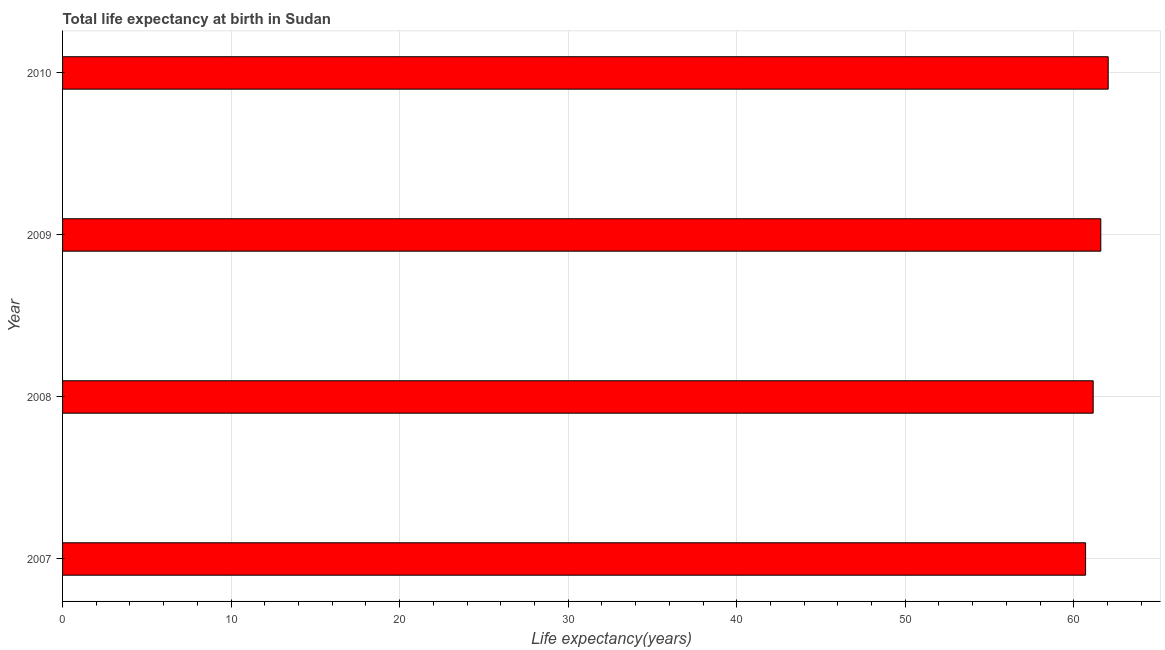Does the graph contain any zero values?
Provide a succinct answer. No. What is the title of the graph?
Your answer should be very brief. Total life expectancy at birth in Sudan. What is the label or title of the X-axis?
Offer a very short reply. Life expectancy(years). What is the label or title of the Y-axis?
Make the answer very short. Year. What is the life expectancy at birth in 2009?
Ensure brevity in your answer.  61.6. Across all years, what is the maximum life expectancy at birth?
Provide a short and direct response. 62.04. Across all years, what is the minimum life expectancy at birth?
Provide a short and direct response. 60.7. In which year was the life expectancy at birth maximum?
Your answer should be compact. 2010. In which year was the life expectancy at birth minimum?
Your answer should be compact. 2007. What is the sum of the life expectancy at birth?
Give a very brief answer. 245.5. What is the difference between the life expectancy at birth in 2009 and 2010?
Offer a very short reply. -0.44. What is the average life expectancy at birth per year?
Make the answer very short. 61.37. What is the median life expectancy at birth?
Give a very brief answer. 61.38. What is the ratio of the life expectancy at birth in 2008 to that in 2009?
Give a very brief answer. 0.99. What is the difference between the highest and the second highest life expectancy at birth?
Give a very brief answer. 0.44. Is the sum of the life expectancy at birth in 2008 and 2009 greater than the maximum life expectancy at birth across all years?
Offer a terse response. Yes. What is the difference between the highest and the lowest life expectancy at birth?
Make the answer very short. 1.34. Are all the bars in the graph horizontal?
Your answer should be compact. Yes. What is the difference between two consecutive major ticks on the X-axis?
Give a very brief answer. 10. What is the Life expectancy(years) of 2007?
Ensure brevity in your answer.  60.7. What is the Life expectancy(years) in 2008?
Make the answer very short. 61.15. What is the Life expectancy(years) in 2009?
Give a very brief answer. 61.6. What is the Life expectancy(years) in 2010?
Make the answer very short. 62.04. What is the difference between the Life expectancy(years) in 2007 and 2008?
Make the answer very short. -0.45. What is the difference between the Life expectancy(years) in 2007 and 2009?
Offer a terse response. -0.9. What is the difference between the Life expectancy(years) in 2007 and 2010?
Offer a terse response. -1.34. What is the difference between the Life expectancy(years) in 2008 and 2009?
Keep it short and to the point. -0.45. What is the difference between the Life expectancy(years) in 2008 and 2010?
Provide a short and direct response. -0.89. What is the difference between the Life expectancy(years) in 2009 and 2010?
Make the answer very short. -0.44. What is the ratio of the Life expectancy(years) in 2007 to that in 2009?
Your response must be concise. 0.98. What is the ratio of the Life expectancy(years) in 2007 to that in 2010?
Make the answer very short. 0.98. What is the ratio of the Life expectancy(years) in 2008 to that in 2009?
Make the answer very short. 0.99. What is the ratio of the Life expectancy(years) in 2008 to that in 2010?
Your answer should be very brief. 0.99. What is the ratio of the Life expectancy(years) in 2009 to that in 2010?
Offer a terse response. 0.99. 